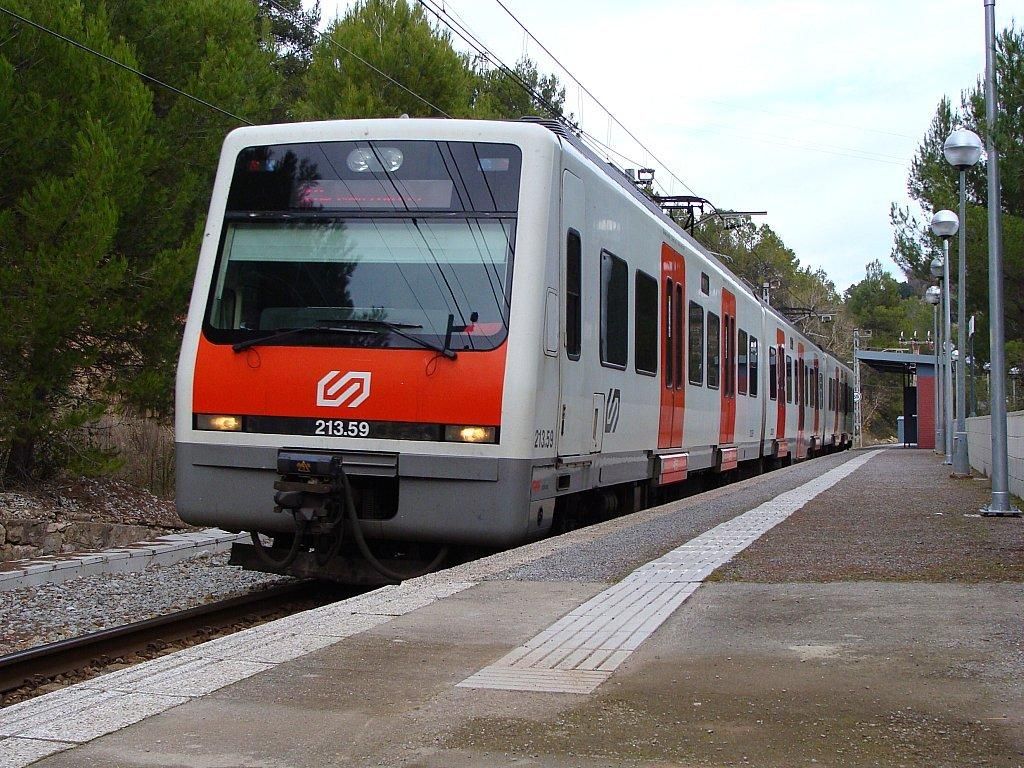What is the main subject of the image? The main subject of the image is a train. Where is the train located in the image? The train is on a railway track. What can be seen along the path in the image? There are street lights on the path. What is visible in the background of the image? There are trees in the background of the image. How many beds can be seen in the image? There are no beds present in the image; it features a train on a railway track with street lights and trees in the background. 